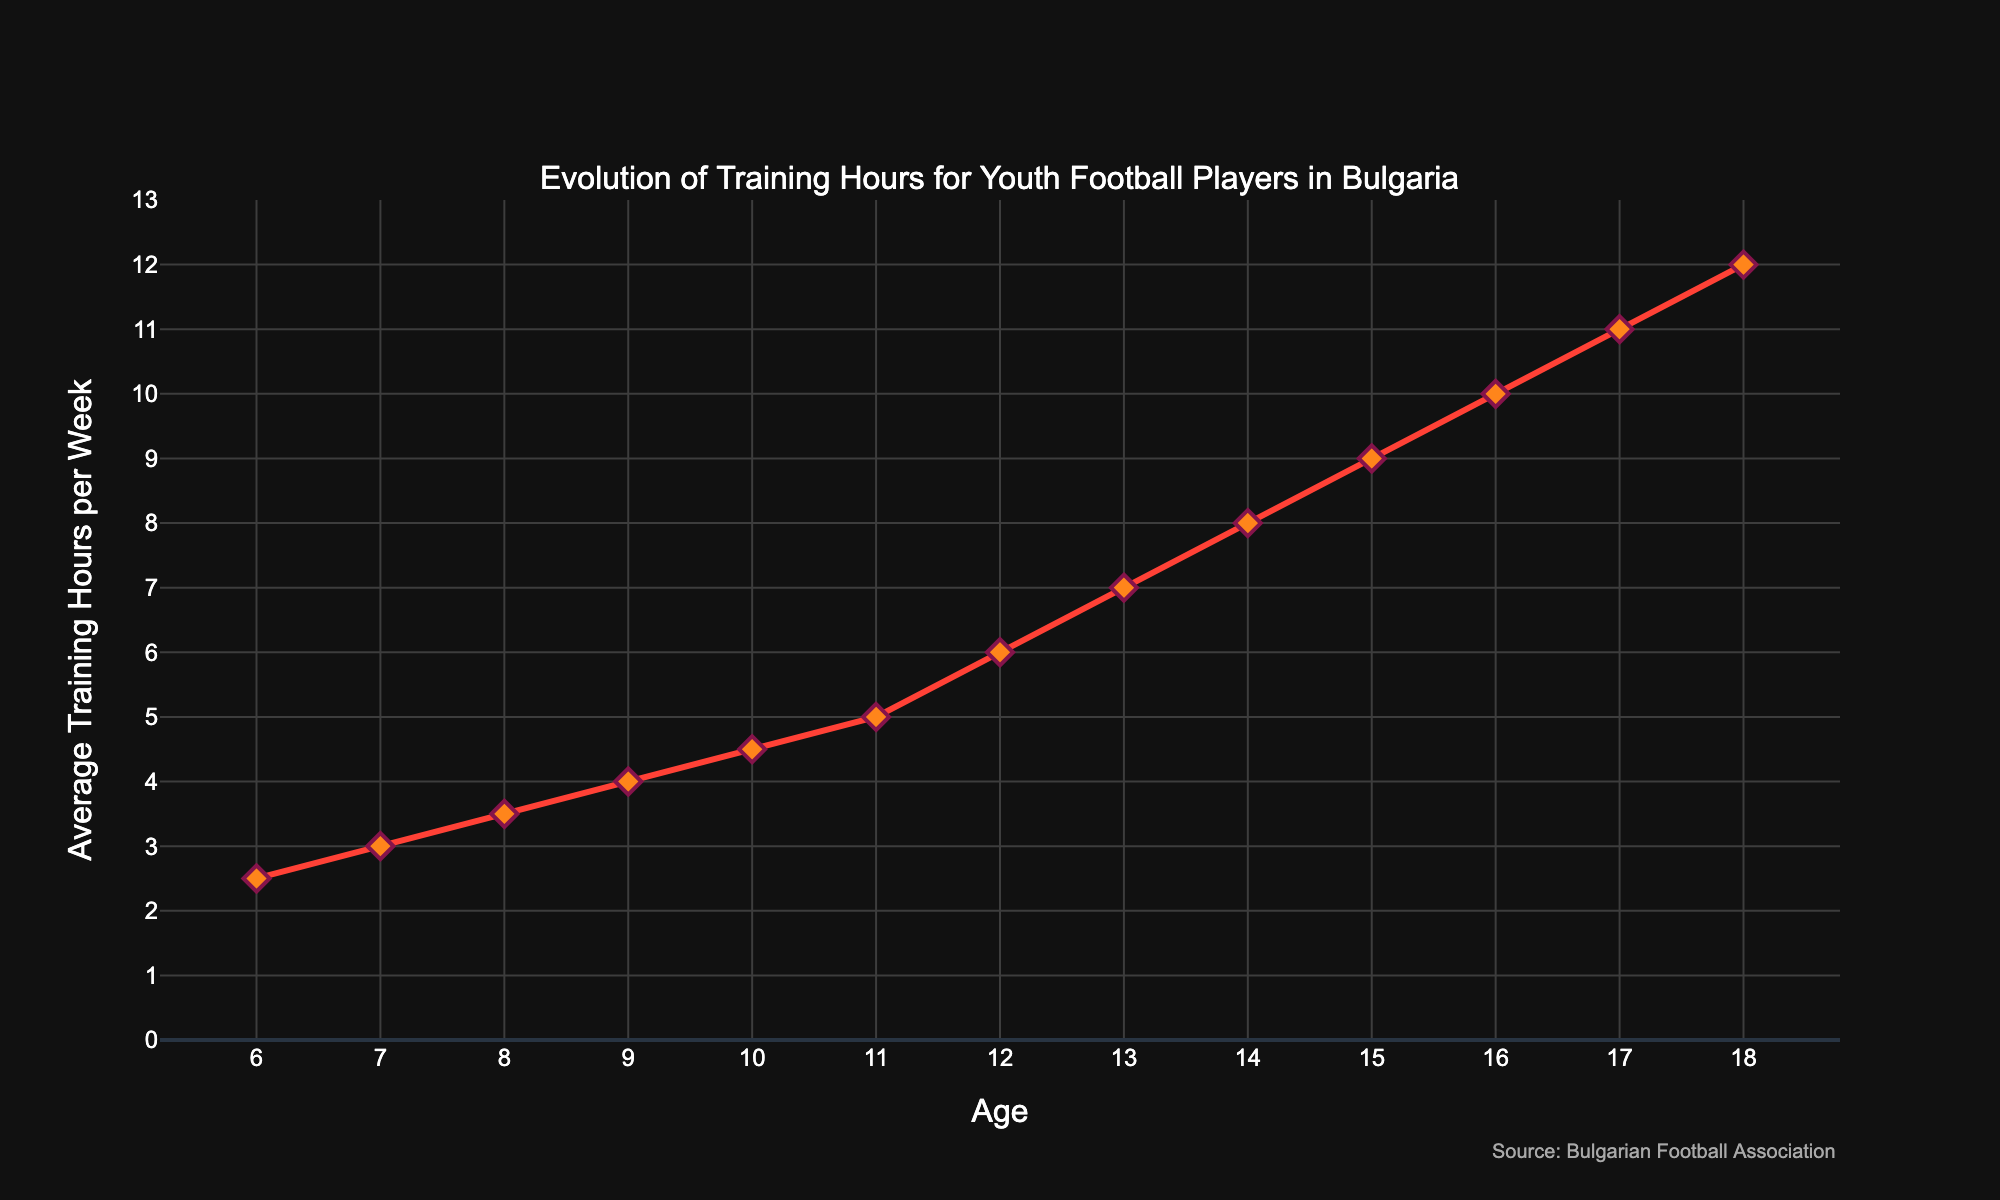What's the average increase in training hours per year from ages 6 to 18? First, calculate the total change in training hours: 12 (at age 18) - 2.5 (at age 6) = 9.5. Next, calculate the number of years: 18 - 6 = 12. Finally, divide the total change by the number of years: 9.5 / 12 ≈ 0.79.
Answer: Approximately 0.79 hours At what age does the average training hours per week reach 7 hours? By inspecting the line chart, the training hours reach 7 hours at age 13.
Answer: Age 13 How much do the training hours increase from age 10 to age 15? Find the training hours at age 15, which is 9, and at age 10, which is 4.5. The increase is 9 - 4.5 = 4.5 hours.
Answer: 4.5 hours Are the training hours more than 6 hours per week for ages 12 and above? By examining the graph, at age 12, training hours are 6, and for ages above 12, the hours are greater than 6.
Answer: Yes What is the range of training hours depicted in the chart? The minimum training hours is 2.5 at age 6, and the maximum is 12 at age 18. The range is 12 - 2.5 = 9.5 hours.
Answer: 9.5 hours Which age has the steepest increase in training hours per week? Observe the slopes between data points: the steepest increase occurs between ages 10 and 11, where the training hours increase from 4.5 to 5, i.e., 0.5 hours in one year.
Answer: Age 10 to 11 Compare the training hours at ages 8 and 16. Which age has more hours and by how much? At age 8, the training hours are 3.5, and at age 16, the hours are 10. The difference is 10 - 3.5 = 6.5 hours.
Answer: Age 16 by 6.5 hours What’s the total sum of average training hours from ages 6 to 10? Sum up the training hours: 2.5 (age 6) + 3 (age 7) + 3.5 (age 8) + 4 (age 9) + 4.5 (age 10) = 17.5 hours.
Answer: 17.5 hours 